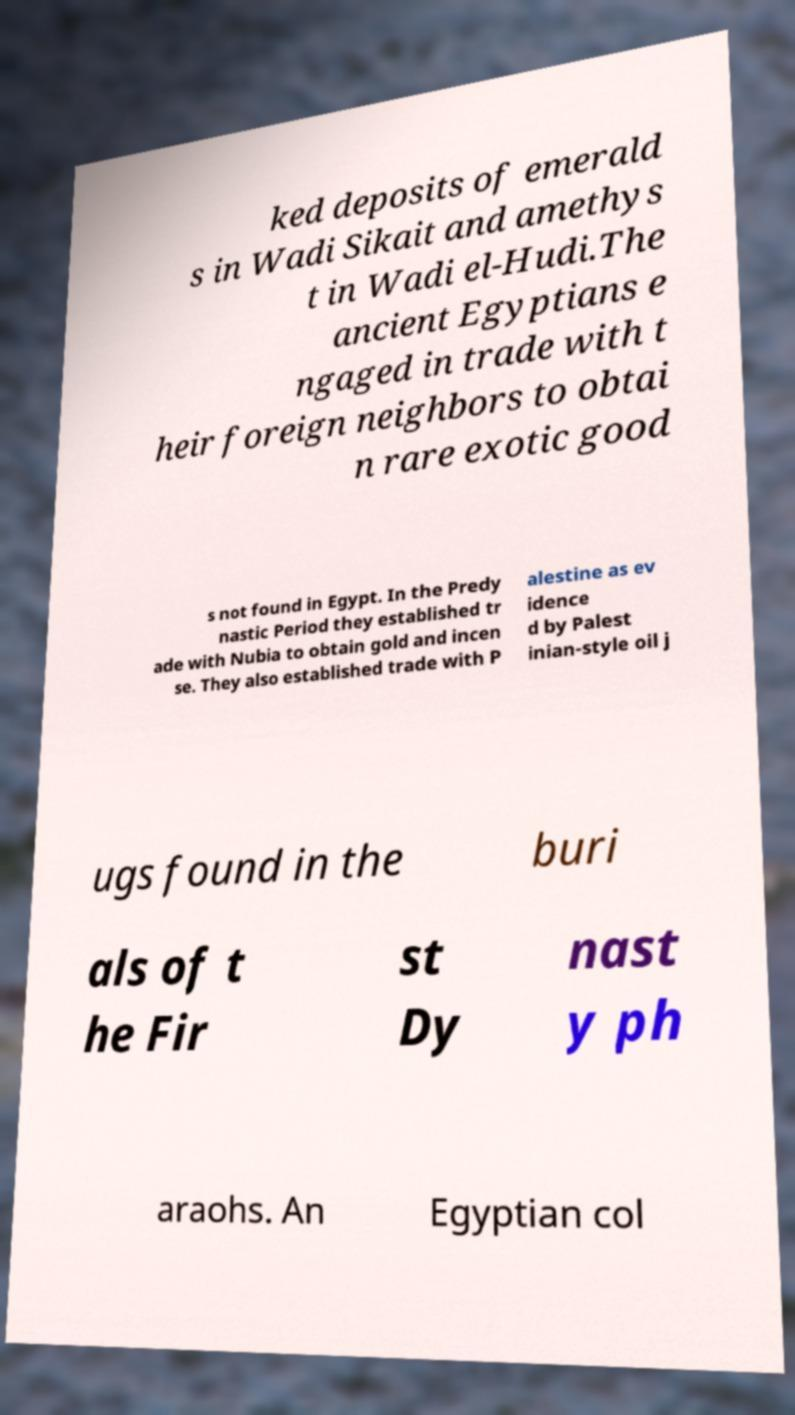What messages or text are displayed in this image? I need them in a readable, typed format. ked deposits of emerald s in Wadi Sikait and amethys t in Wadi el-Hudi.The ancient Egyptians e ngaged in trade with t heir foreign neighbors to obtai n rare exotic good s not found in Egypt. In the Predy nastic Period they established tr ade with Nubia to obtain gold and incen se. They also established trade with P alestine as ev idence d by Palest inian-style oil j ugs found in the buri als of t he Fir st Dy nast y ph araohs. An Egyptian col 